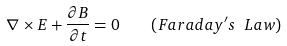<formula> <loc_0><loc_0><loc_500><loc_500>\nabla \times E + \frac { \partial B } { \partial t } = 0 \quad ( F a r a d a y ^ { \prime } s \ L a w )</formula> 